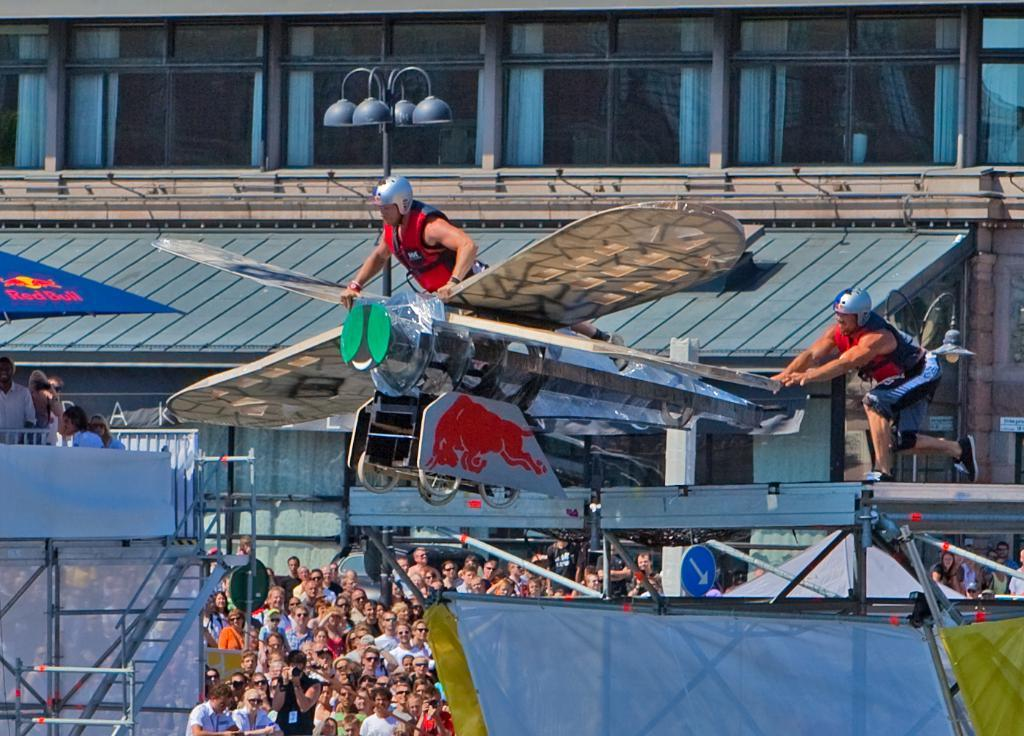How many people are in the group visible in the image? The number of people in the group cannot be determined from the provided facts. What can be seen in the background of the image? There is a building in the background of the image. What feature of the building is mentioned in the facts? The building has a roof. What type of receipt can be seen in the hands of one of the people in the image? There is no mention of a receipt in the provided facts, so it cannot be determined if any person in the image is holding a receipt. Can you tell me if there are any pickles visible in the image? There is no mention of pickles in the provided facts, so it cannot be determined if any pickles are visible in the image. 